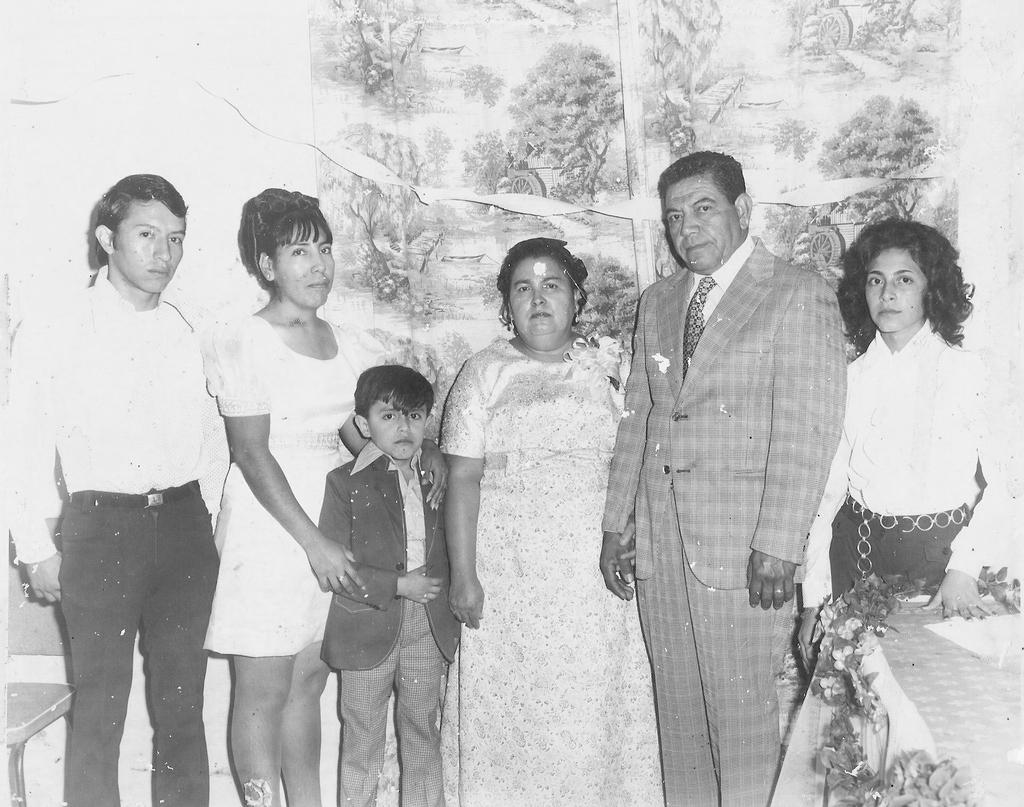How many people are in the image? There is a group of people in the image. What are the people doing in the image? The people are standing. What can be seen in the background of the image? There is a wall in the background of the image. What is on the wall in the image? There is a photo frame on the wall. What type of shirt is the ship wearing in the image? There is no ship present in the image, and therefore no shirt or ship can be observed. Is there a birthday celebration happening in the image? There is no indication of a birthday celebration in the image. 